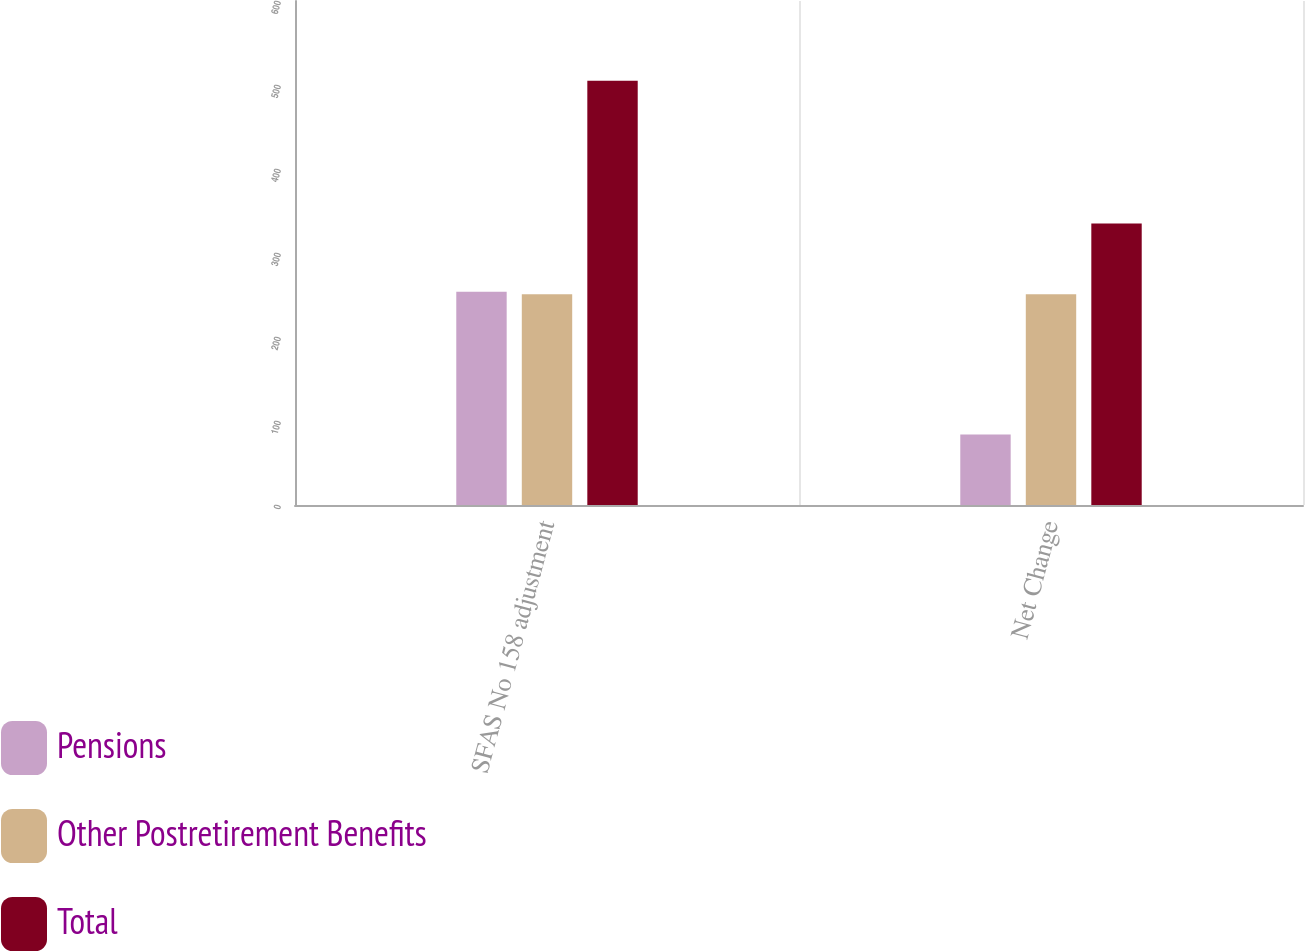Convert chart to OTSL. <chart><loc_0><loc_0><loc_500><loc_500><stacked_bar_chart><ecel><fcel>SFAS No 158 adjustment<fcel>Net Change<nl><fcel>Pensions<fcel>254<fcel>84<nl><fcel>Other Postretirement Benefits<fcel>251<fcel>251<nl><fcel>Total<fcel>505<fcel>335<nl></chart> 